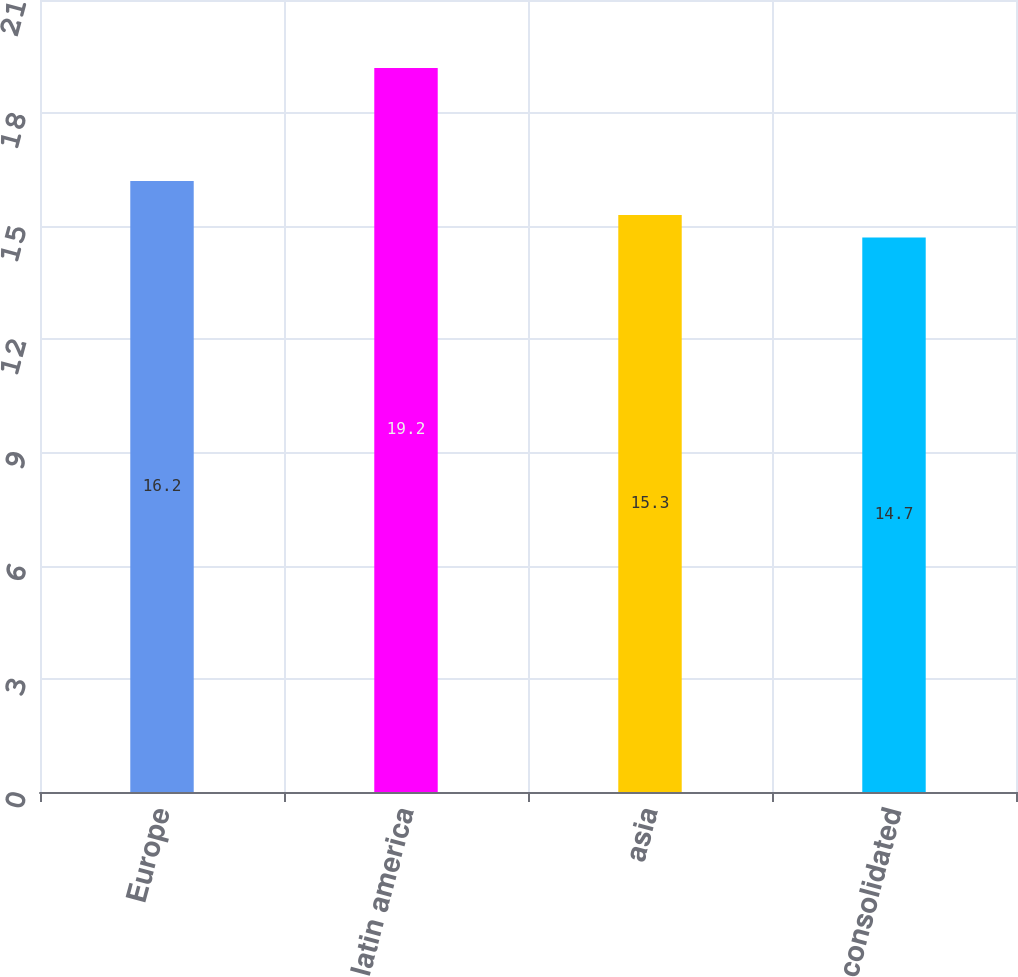<chart> <loc_0><loc_0><loc_500><loc_500><bar_chart><fcel>Europe<fcel>latin america<fcel>asia<fcel>consolidated<nl><fcel>16.2<fcel>19.2<fcel>15.3<fcel>14.7<nl></chart> 